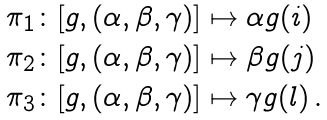Convert formula to latex. <formula><loc_0><loc_0><loc_500><loc_500>\begin{array} { l } \pi _ { 1 } \colon [ g , ( \alpha , \beta , \gamma ) ] \mapsto \alpha g ( i ) \\ \pi _ { 2 } \colon [ g , ( \alpha , \beta , \gamma ) ] \mapsto \beta g ( j ) \\ \pi _ { 3 } \colon [ g , ( \alpha , \beta , \gamma ) ] \mapsto \gamma g ( l ) \, . \end{array}</formula> 